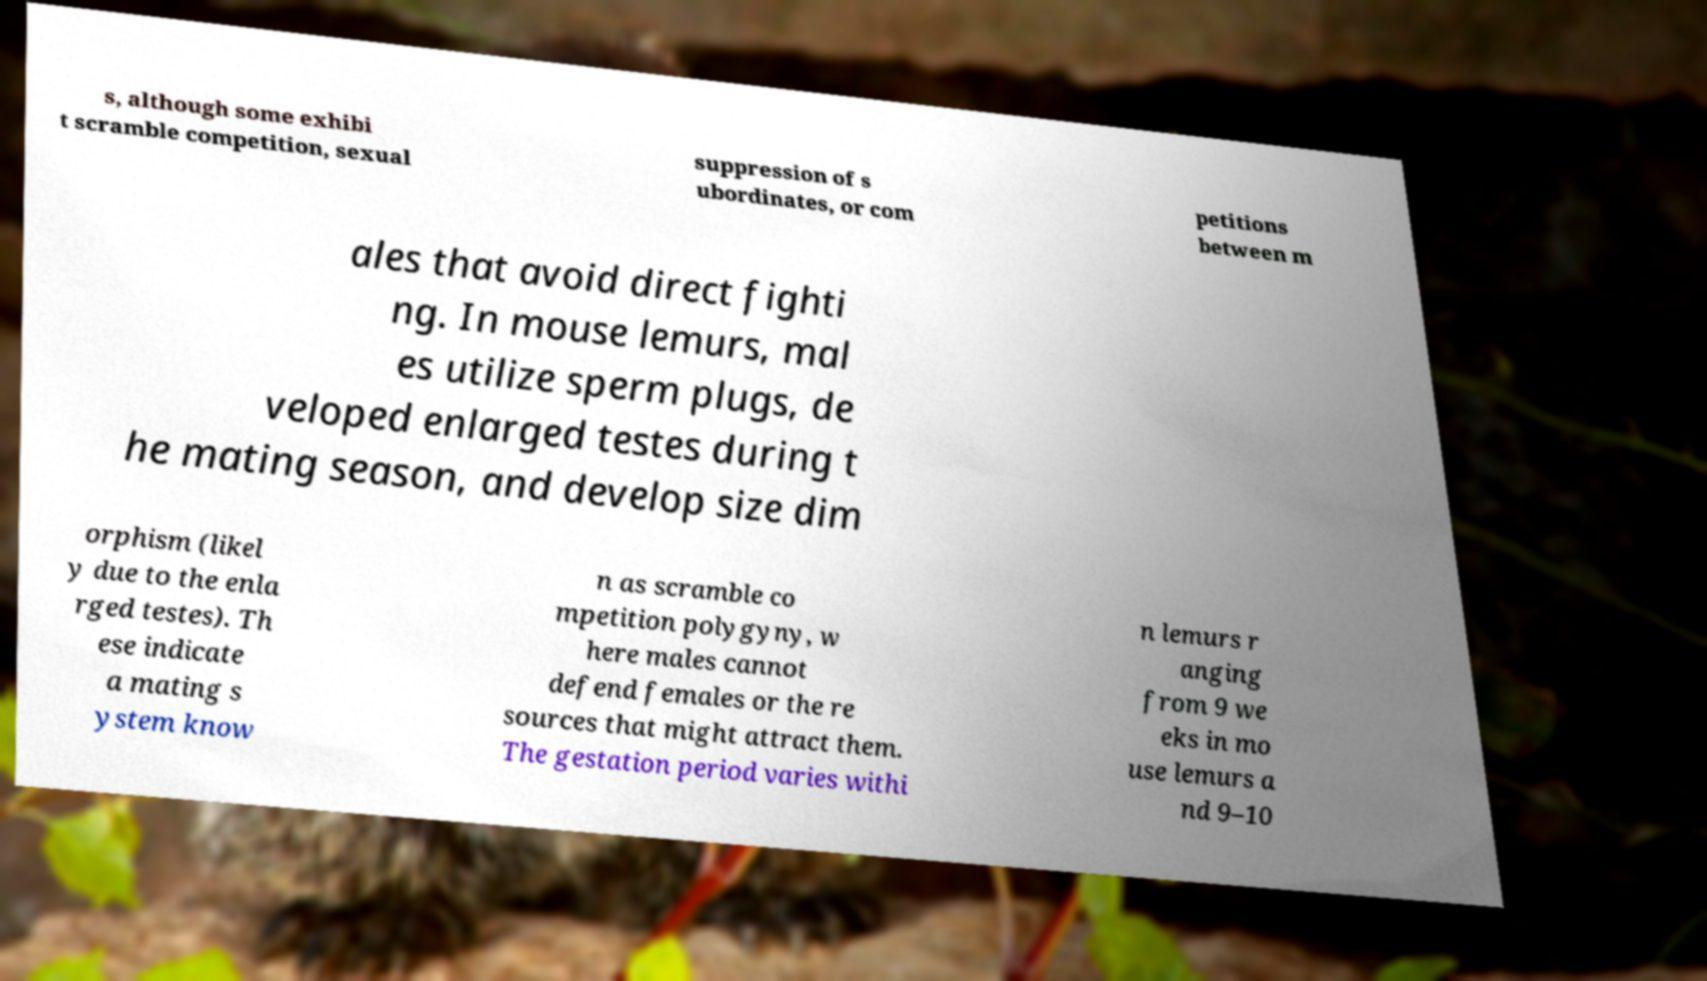Please identify and transcribe the text found in this image. s, although some exhibi t scramble competition, sexual suppression of s ubordinates, or com petitions between m ales that avoid direct fighti ng. In mouse lemurs, mal es utilize sperm plugs, de veloped enlarged testes during t he mating season, and develop size dim orphism (likel y due to the enla rged testes). Th ese indicate a mating s ystem know n as scramble co mpetition polygyny, w here males cannot defend females or the re sources that might attract them. The gestation period varies withi n lemurs r anging from 9 we eks in mo use lemurs a nd 9–10 